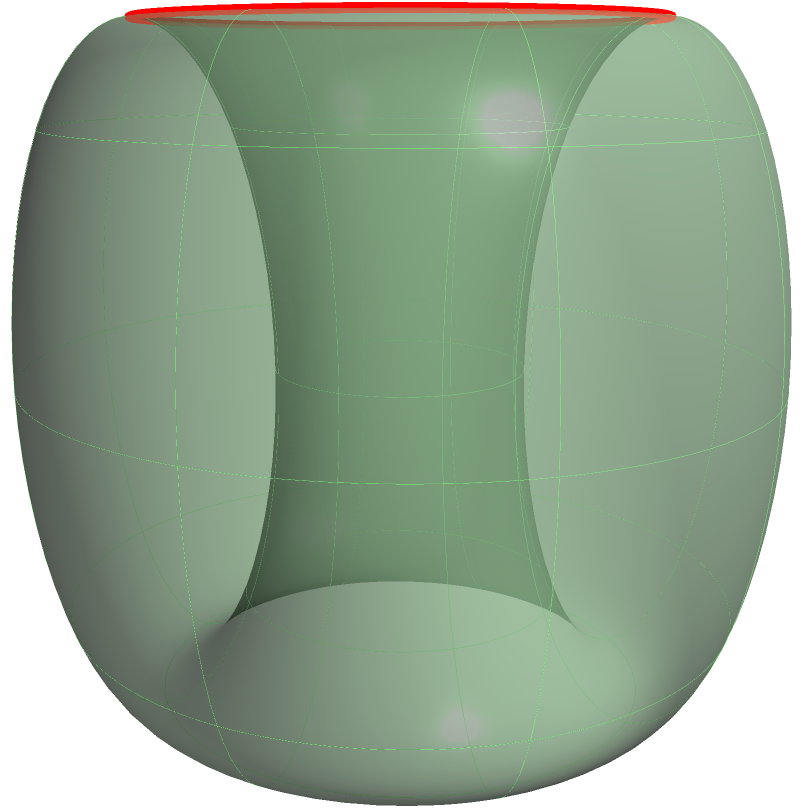In the context of the Poincaré conjecture, what topological property does the green surface in the image represent, and how does the red loop relate to this property? To understand this visualization in relation to the Poincaré conjecture:

1. The green surface represents a 2-dimensional manifold embedded in 3D space, specifically a torus.

2. The Poincaré conjecture, proven by Grigori Perelman, states that every simply connected, closed 3-manifold is homeomorphic to the 3-sphere.

3. While we're looking at a 2D surface, it helps visualize concepts related to 3D manifolds.

4. The red loop on the surface is a non-contractible loop. It cannot be continuously shrunk to a point while staying on the surface.

5. This non-contractible loop is key: its existence proves that this surface is not simply connected, and thus not homeomorphic to a sphere.

6. In contrast, on a sphere (or any simply connected surface), every loop can be continuously contracted to a point.

7. The Poincaré conjecture extends this idea to 3D: if every loop in a closed 3-manifold can be contracted to a point, the manifold is homeomorphic to a 3-sphere.

8. This visualization helps understand the concept of simple connectedness, which is crucial to the Poincaré conjecture, even though it's showing a lower-dimensional analogue.
Answer: The surface represents a non-simply connected manifold (torus), with the red loop demonstrating a non-contractible path, contrasting with the Poincaré conjecture's focus on simply connected 3-manifolds. 